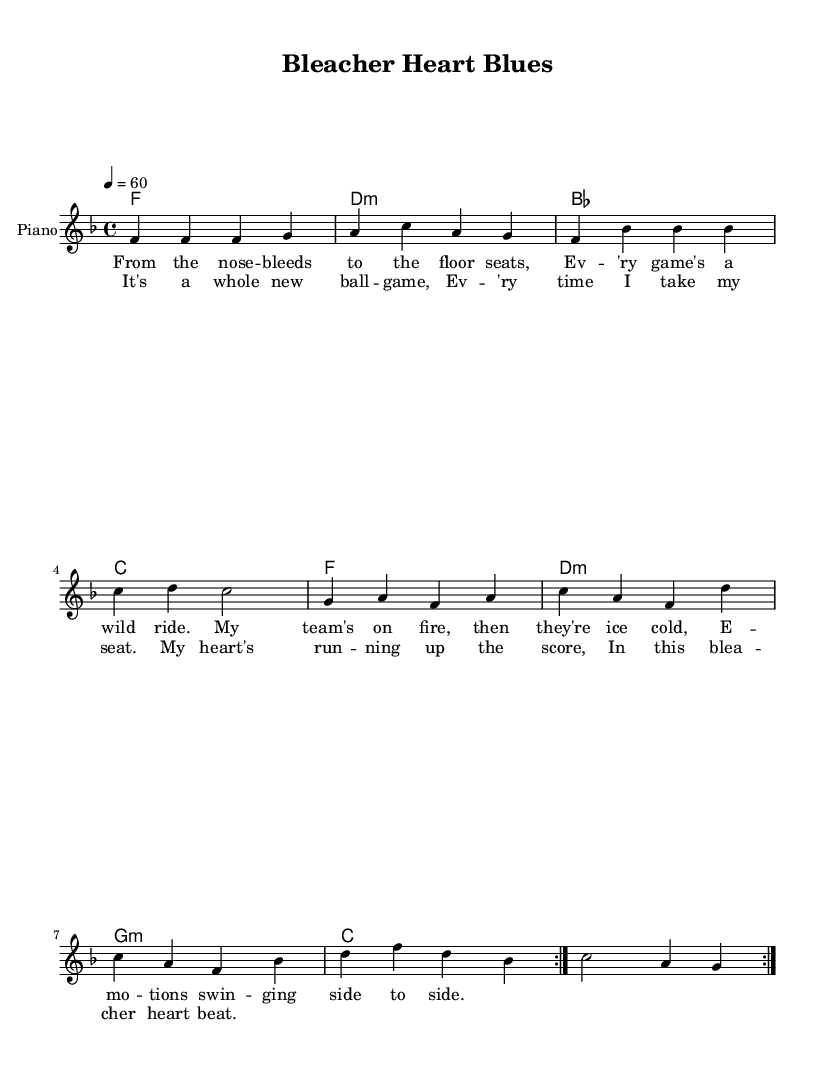What is the key signature of this music? The key signature is F major, which has one flat (B flat). This can be identified by looking at the key signature section at the beginning of the piece.
Answer: F major What is the time signature of the piece? The time signature is 4/4, which means there are four beats in each measure and the quarter note receives one beat. This information is indicated at the start of the sheet music.
Answer: 4/4 What is the tempo marking for this composition? The tempo marking is 60 beats per minute. This is indicated by the tempo text that specifies how fast the music should be played, which is found at the beginning of the score.
Answer: 60 How many times is the melody repeated? The melody is repeated 2 times, as indicated by the "repeat" markings present in the melody section of the sheet music.
Answer: 2 What is the tonic chord of the harmony section? The tonic chord is F major, which is the first chord in the harmony part. It establishes the key of the piece and is identified by reading the first chord displayed in the harmonic progression.
Answer: F What thematic topic is reflected in the lyrics? The lyrics vividly express the emotional ups and downs of being a sports fan. They highlight the connection between the fan's feelings and the team's performance, showcasing euphoria and despair as part of the experience. This can be analyzed by the content of the verses and chorus descriptions.
Answer: Being a sports fan What does "bleacher heart" symbolize in the title and lyrics? "Bleacher heart" symbolizes the passionate yet tumultuous feelings of a dedicated sports fan, often feeling excitement and disappointment. This metaphor can be deciphered from the context of the lyrics and title that focus on the highs and lows of sports fandom.
Answer: Passionate yet tumultuous fan emotions 